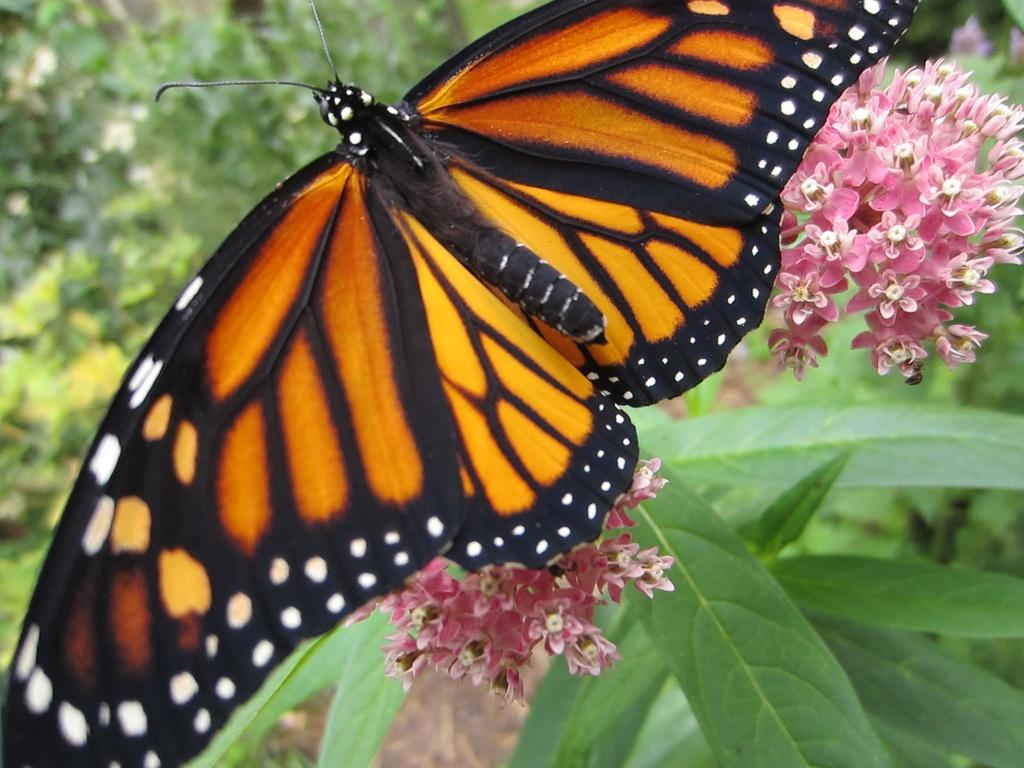What type of animal can be seen in the image? There is a butterfly in the image. What is the butterfly sitting on or near in the image? The butterfly is near flowers on a plant in the image. What can be seen in the background of the image? Greenery is visible in the background of the image. What type of train can be seen in the image? There is no train present in the image; it features a butterfly and flowers on a plant. What type of vase is holding the twig in the image? There is no vase or twig present in the image. 